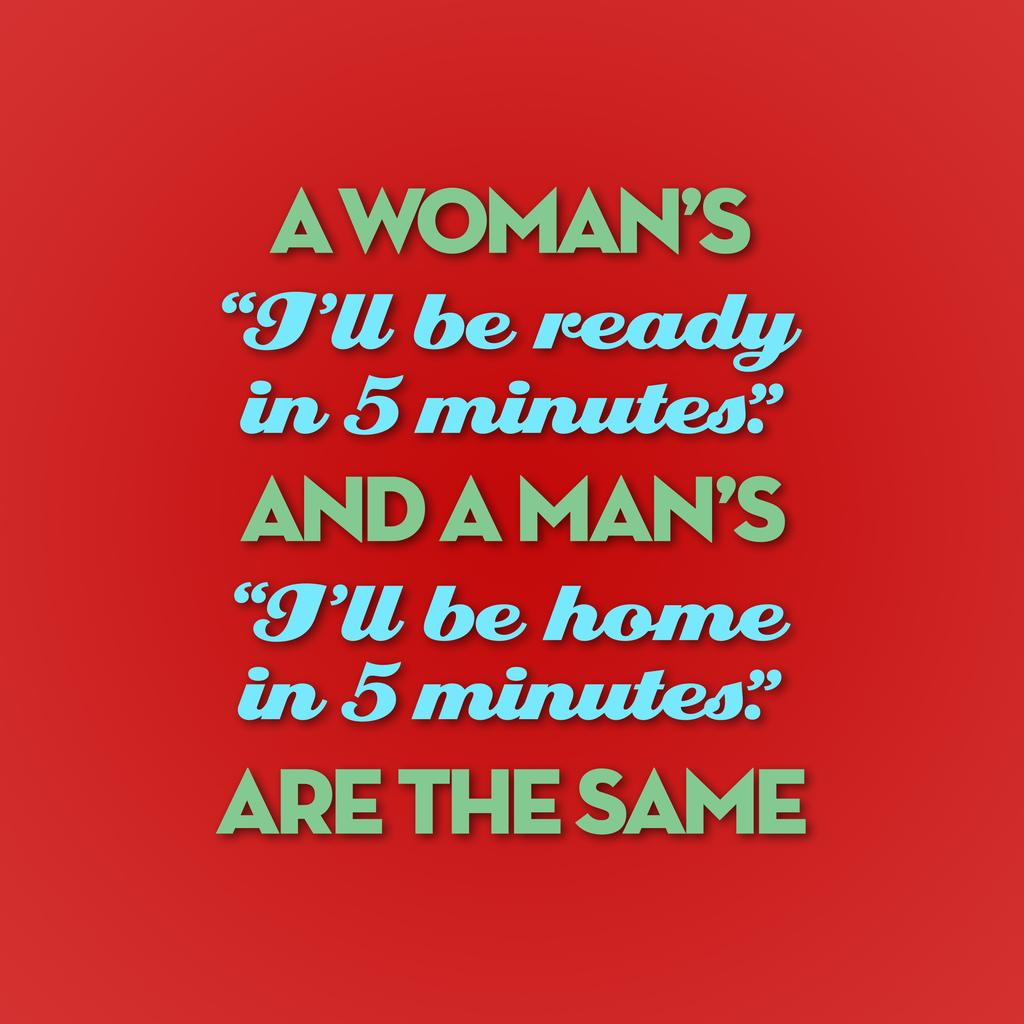<image>
Give a short and clear explanation of the subsequent image. A funny card reads "A woman's I'll be ready in 5 minutes and a Man's I'll be home in 5 minutes" are the same 